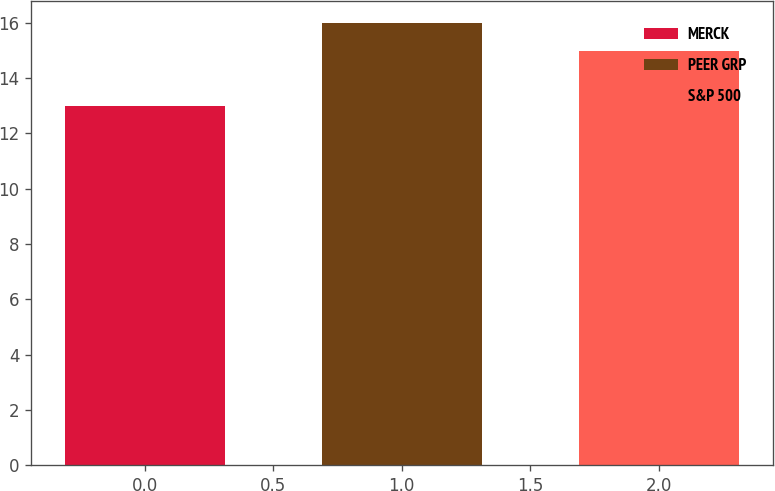Convert chart to OTSL. <chart><loc_0><loc_0><loc_500><loc_500><bar_chart><fcel>MERCK<fcel>PEER GRP<fcel>S&P 500<nl><fcel>13<fcel>16<fcel>15<nl></chart> 